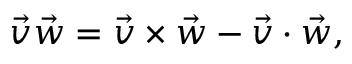<formula> <loc_0><loc_0><loc_500><loc_500>{ \vec { v } } { \vec { w } } = { \vec { v } } \times { \vec { w } } - { \vec { v } } \cdot { \vec { w } } ,</formula> 